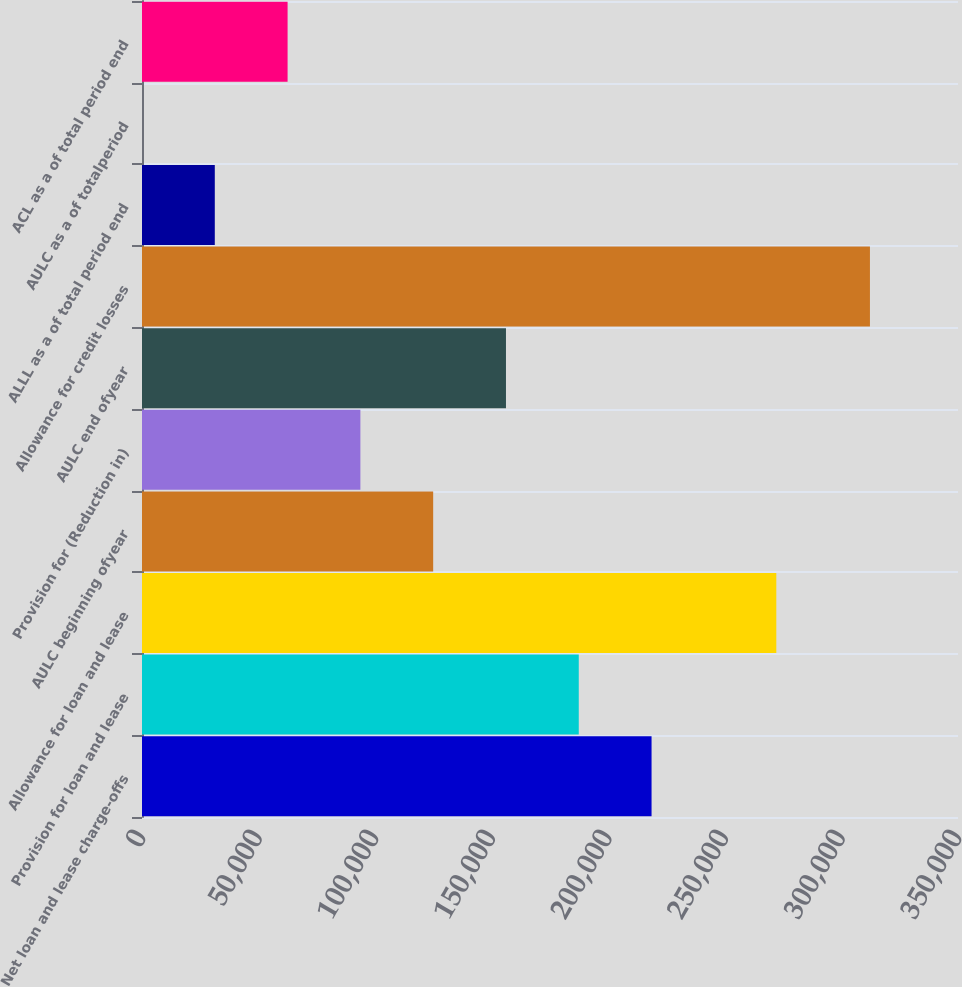Convert chart. <chart><loc_0><loc_0><loc_500><loc_500><bar_chart><fcel>Net loan and lease charge-offs<fcel>Provision for loan and lease<fcel>Allowance for loan and lease<fcel>AULC beginning ofyear<fcel>Provision for (Reduction in)<fcel>AULC end ofyear<fcel>Allowance for credit losses<fcel>ALLL as a of total period end<fcel>AULC as a of totalperiod<fcel>ACL as a of total period end<nl><fcel>218560<fcel>187337<fcel>272068<fcel>124892<fcel>93668.8<fcel>156115<fcel>312229<fcel>31223<fcel>0.15<fcel>62445.9<nl></chart> 